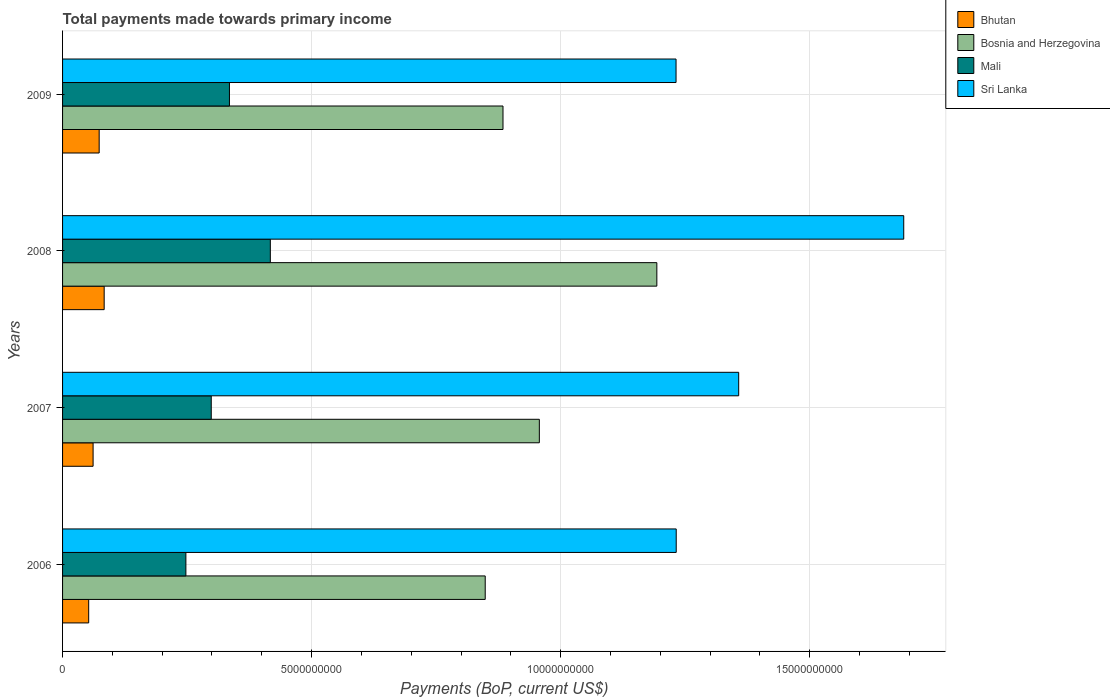How many groups of bars are there?
Provide a short and direct response. 4. How many bars are there on the 2nd tick from the top?
Provide a succinct answer. 4. What is the total payments made towards primary income in Mali in 2009?
Provide a short and direct response. 3.35e+09. Across all years, what is the maximum total payments made towards primary income in Sri Lanka?
Your answer should be very brief. 1.69e+1. Across all years, what is the minimum total payments made towards primary income in Sri Lanka?
Ensure brevity in your answer.  1.23e+1. What is the total total payments made towards primary income in Mali in the graph?
Give a very brief answer. 1.30e+1. What is the difference between the total payments made towards primary income in Mali in 2007 and that in 2009?
Your response must be concise. -3.65e+08. What is the difference between the total payments made towards primary income in Bosnia and Herzegovina in 2006 and the total payments made towards primary income in Mali in 2008?
Your answer should be very brief. 4.31e+09. What is the average total payments made towards primary income in Mali per year?
Offer a very short reply. 3.25e+09. In the year 2009, what is the difference between the total payments made towards primary income in Sri Lanka and total payments made towards primary income in Bosnia and Herzegovina?
Provide a short and direct response. 3.47e+09. What is the ratio of the total payments made towards primary income in Bosnia and Herzegovina in 2006 to that in 2008?
Ensure brevity in your answer.  0.71. Is the total payments made towards primary income in Bhutan in 2006 less than that in 2008?
Keep it short and to the point. Yes. Is the difference between the total payments made towards primary income in Sri Lanka in 2006 and 2009 greater than the difference between the total payments made towards primary income in Bosnia and Herzegovina in 2006 and 2009?
Your response must be concise. Yes. What is the difference between the highest and the second highest total payments made towards primary income in Mali?
Keep it short and to the point. 8.21e+08. What is the difference between the highest and the lowest total payments made towards primary income in Bosnia and Herzegovina?
Your answer should be very brief. 3.45e+09. Is it the case that in every year, the sum of the total payments made towards primary income in Bosnia and Herzegovina and total payments made towards primary income in Bhutan is greater than the sum of total payments made towards primary income in Sri Lanka and total payments made towards primary income in Mali?
Ensure brevity in your answer.  No. What does the 3rd bar from the top in 2007 represents?
Your response must be concise. Bosnia and Herzegovina. What does the 3rd bar from the bottom in 2009 represents?
Provide a succinct answer. Mali. How many bars are there?
Ensure brevity in your answer.  16. What is the difference between two consecutive major ticks on the X-axis?
Provide a succinct answer. 5.00e+09. Are the values on the major ticks of X-axis written in scientific E-notation?
Give a very brief answer. No. Does the graph contain any zero values?
Ensure brevity in your answer.  No. Where does the legend appear in the graph?
Offer a very short reply. Top right. What is the title of the graph?
Your answer should be very brief. Total payments made towards primary income. What is the label or title of the X-axis?
Offer a terse response. Payments (BoP, current US$). What is the label or title of the Y-axis?
Offer a very short reply. Years. What is the Payments (BoP, current US$) in Bhutan in 2006?
Keep it short and to the point. 5.25e+08. What is the Payments (BoP, current US$) in Bosnia and Herzegovina in 2006?
Keep it short and to the point. 8.49e+09. What is the Payments (BoP, current US$) in Mali in 2006?
Give a very brief answer. 2.48e+09. What is the Payments (BoP, current US$) of Sri Lanka in 2006?
Give a very brief answer. 1.23e+1. What is the Payments (BoP, current US$) of Bhutan in 2007?
Offer a terse response. 6.13e+08. What is the Payments (BoP, current US$) of Bosnia and Herzegovina in 2007?
Give a very brief answer. 9.57e+09. What is the Payments (BoP, current US$) of Mali in 2007?
Ensure brevity in your answer.  2.99e+09. What is the Payments (BoP, current US$) of Sri Lanka in 2007?
Your answer should be very brief. 1.36e+1. What is the Payments (BoP, current US$) of Bhutan in 2008?
Your response must be concise. 8.35e+08. What is the Payments (BoP, current US$) in Bosnia and Herzegovina in 2008?
Offer a very short reply. 1.19e+1. What is the Payments (BoP, current US$) of Mali in 2008?
Give a very brief answer. 4.17e+09. What is the Payments (BoP, current US$) of Sri Lanka in 2008?
Ensure brevity in your answer.  1.69e+1. What is the Payments (BoP, current US$) in Bhutan in 2009?
Make the answer very short. 7.35e+08. What is the Payments (BoP, current US$) of Bosnia and Herzegovina in 2009?
Make the answer very short. 8.84e+09. What is the Payments (BoP, current US$) of Mali in 2009?
Make the answer very short. 3.35e+09. What is the Payments (BoP, current US$) of Sri Lanka in 2009?
Offer a terse response. 1.23e+1. Across all years, what is the maximum Payments (BoP, current US$) of Bhutan?
Give a very brief answer. 8.35e+08. Across all years, what is the maximum Payments (BoP, current US$) of Bosnia and Herzegovina?
Your response must be concise. 1.19e+1. Across all years, what is the maximum Payments (BoP, current US$) in Mali?
Offer a very short reply. 4.17e+09. Across all years, what is the maximum Payments (BoP, current US$) of Sri Lanka?
Make the answer very short. 1.69e+1. Across all years, what is the minimum Payments (BoP, current US$) of Bhutan?
Offer a very short reply. 5.25e+08. Across all years, what is the minimum Payments (BoP, current US$) in Bosnia and Herzegovina?
Provide a short and direct response. 8.49e+09. Across all years, what is the minimum Payments (BoP, current US$) in Mali?
Your response must be concise. 2.48e+09. Across all years, what is the minimum Payments (BoP, current US$) of Sri Lanka?
Give a very brief answer. 1.23e+1. What is the total Payments (BoP, current US$) in Bhutan in the graph?
Offer a terse response. 2.71e+09. What is the total Payments (BoP, current US$) in Bosnia and Herzegovina in the graph?
Provide a short and direct response. 3.88e+1. What is the total Payments (BoP, current US$) in Mali in the graph?
Your answer should be very brief. 1.30e+1. What is the total Payments (BoP, current US$) in Sri Lanka in the graph?
Offer a very short reply. 5.51e+1. What is the difference between the Payments (BoP, current US$) of Bhutan in 2006 and that in 2007?
Offer a very short reply. -8.84e+07. What is the difference between the Payments (BoP, current US$) in Bosnia and Herzegovina in 2006 and that in 2007?
Give a very brief answer. -1.09e+09. What is the difference between the Payments (BoP, current US$) in Mali in 2006 and that in 2007?
Provide a short and direct response. -5.09e+08. What is the difference between the Payments (BoP, current US$) of Sri Lanka in 2006 and that in 2007?
Your response must be concise. -1.25e+09. What is the difference between the Payments (BoP, current US$) in Bhutan in 2006 and that in 2008?
Ensure brevity in your answer.  -3.11e+08. What is the difference between the Payments (BoP, current US$) of Bosnia and Herzegovina in 2006 and that in 2008?
Your response must be concise. -3.45e+09. What is the difference between the Payments (BoP, current US$) of Mali in 2006 and that in 2008?
Keep it short and to the point. -1.70e+09. What is the difference between the Payments (BoP, current US$) in Sri Lanka in 2006 and that in 2008?
Make the answer very short. -4.57e+09. What is the difference between the Payments (BoP, current US$) of Bhutan in 2006 and that in 2009?
Your response must be concise. -2.10e+08. What is the difference between the Payments (BoP, current US$) in Bosnia and Herzegovina in 2006 and that in 2009?
Your response must be concise. -3.57e+08. What is the difference between the Payments (BoP, current US$) in Mali in 2006 and that in 2009?
Make the answer very short. -8.75e+08. What is the difference between the Payments (BoP, current US$) in Sri Lanka in 2006 and that in 2009?
Provide a short and direct response. 3.42e+06. What is the difference between the Payments (BoP, current US$) of Bhutan in 2007 and that in 2008?
Make the answer very short. -2.22e+08. What is the difference between the Payments (BoP, current US$) in Bosnia and Herzegovina in 2007 and that in 2008?
Keep it short and to the point. -2.36e+09. What is the difference between the Payments (BoP, current US$) in Mali in 2007 and that in 2008?
Keep it short and to the point. -1.19e+09. What is the difference between the Payments (BoP, current US$) in Sri Lanka in 2007 and that in 2008?
Your response must be concise. -3.31e+09. What is the difference between the Payments (BoP, current US$) of Bhutan in 2007 and that in 2009?
Keep it short and to the point. -1.22e+08. What is the difference between the Payments (BoP, current US$) in Bosnia and Herzegovina in 2007 and that in 2009?
Keep it short and to the point. 7.30e+08. What is the difference between the Payments (BoP, current US$) of Mali in 2007 and that in 2009?
Your answer should be very brief. -3.65e+08. What is the difference between the Payments (BoP, current US$) of Sri Lanka in 2007 and that in 2009?
Your response must be concise. 1.26e+09. What is the difference between the Payments (BoP, current US$) in Bhutan in 2008 and that in 2009?
Ensure brevity in your answer.  1.00e+08. What is the difference between the Payments (BoP, current US$) of Bosnia and Herzegovina in 2008 and that in 2009?
Ensure brevity in your answer.  3.09e+09. What is the difference between the Payments (BoP, current US$) in Mali in 2008 and that in 2009?
Your answer should be very brief. 8.21e+08. What is the difference between the Payments (BoP, current US$) in Sri Lanka in 2008 and that in 2009?
Give a very brief answer. 4.57e+09. What is the difference between the Payments (BoP, current US$) of Bhutan in 2006 and the Payments (BoP, current US$) of Bosnia and Herzegovina in 2007?
Give a very brief answer. -9.05e+09. What is the difference between the Payments (BoP, current US$) in Bhutan in 2006 and the Payments (BoP, current US$) in Mali in 2007?
Provide a short and direct response. -2.46e+09. What is the difference between the Payments (BoP, current US$) of Bhutan in 2006 and the Payments (BoP, current US$) of Sri Lanka in 2007?
Keep it short and to the point. -1.31e+1. What is the difference between the Payments (BoP, current US$) of Bosnia and Herzegovina in 2006 and the Payments (BoP, current US$) of Mali in 2007?
Provide a short and direct response. 5.50e+09. What is the difference between the Payments (BoP, current US$) of Bosnia and Herzegovina in 2006 and the Payments (BoP, current US$) of Sri Lanka in 2007?
Provide a short and direct response. -5.09e+09. What is the difference between the Payments (BoP, current US$) of Mali in 2006 and the Payments (BoP, current US$) of Sri Lanka in 2007?
Your answer should be compact. -1.11e+1. What is the difference between the Payments (BoP, current US$) of Bhutan in 2006 and the Payments (BoP, current US$) of Bosnia and Herzegovina in 2008?
Keep it short and to the point. -1.14e+1. What is the difference between the Payments (BoP, current US$) in Bhutan in 2006 and the Payments (BoP, current US$) in Mali in 2008?
Offer a terse response. -3.65e+09. What is the difference between the Payments (BoP, current US$) of Bhutan in 2006 and the Payments (BoP, current US$) of Sri Lanka in 2008?
Your response must be concise. -1.64e+1. What is the difference between the Payments (BoP, current US$) in Bosnia and Herzegovina in 2006 and the Payments (BoP, current US$) in Mali in 2008?
Your answer should be very brief. 4.31e+09. What is the difference between the Payments (BoP, current US$) of Bosnia and Herzegovina in 2006 and the Payments (BoP, current US$) of Sri Lanka in 2008?
Keep it short and to the point. -8.40e+09. What is the difference between the Payments (BoP, current US$) of Mali in 2006 and the Payments (BoP, current US$) of Sri Lanka in 2008?
Offer a very short reply. -1.44e+1. What is the difference between the Payments (BoP, current US$) in Bhutan in 2006 and the Payments (BoP, current US$) in Bosnia and Herzegovina in 2009?
Offer a very short reply. -8.32e+09. What is the difference between the Payments (BoP, current US$) of Bhutan in 2006 and the Payments (BoP, current US$) of Mali in 2009?
Your answer should be compact. -2.83e+09. What is the difference between the Payments (BoP, current US$) of Bhutan in 2006 and the Payments (BoP, current US$) of Sri Lanka in 2009?
Your answer should be compact. -1.18e+1. What is the difference between the Payments (BoP, current US$) in Bosnia and Herzegovina in 2006 and the Payments (BoP, current US$) in Mali in 2009?
Offer a very short reply. 5.14e+09. What is the difference between the Payments (BoP, current US$) in Bosnia and Herzegovina in 2006 and the Payments (BoP, current US$) in Sri Lanka in 2009?
Provide a succinct answer. -3.83e+09. What is the difference between the Payments (BoP, current US$) of Mali in 2006 and the Payments (BoP, current US$) of Sri Lanka in 2009?
Your answer should be compact. -9.84e+09. What is the difference between the Payments (BoP, current US$) of Bhutan in 2007 and the Payments (BoP, current US$) of Bosnia and Herzegovina in 2008?
Provide a short and direct response. -1.13e+1. What is the difference between the Payments (BoP, current US$) of Bhutan in 2007 and the Payments (BoP, current US$) of Mali in 2008?
Keep it short and to the point. -3.56e+09. What is the difference between the Payments (BoP, current US$) in Bhutan in 2007 and the Payments (BoP, current US$) in Sri Lanka in 2008?
Provide a succinct answer. -1.63e+1. What is the difference between the Payments (BoP, current US$) in Bosnia and Herzegovina in 2007 and the Payments (BoP, current US$) in Mali in 2008?
Your response must be concise. 5.40e+09. What is the difference between the Payments (BoP, current US$) of Bosnia and Herzegovina in 2007 and the Payments (BoP, current US$) of Sri Lanka in 2008?
Your answer should be compact. -7.32e+09. What is the difference between the Payments (BoP, current US$) of Mali in 2007 and the Payments (BoP, current US$) of Sri Lanka in 2008?
Offer a terse response. -1.39e+1. What is the difference between the Payments (BoP, current US$) in Bhutan in 2007 and the Payments (BoP, current US$) in Bosnia and Herzegovina in 2009?
Your answer should be compact. -8.23e+09. What is the difference between the Payments (BoP, current US$) of Bhutan in 2007 and the Payments (BoP, current US$) of Mali in 2009?
Give a very brief answer. -2.74e+09. What is the difference between the Payments (BoP, current US$) in Bhutan in 2007 and the Payments (BoP, current US$) in Sri Lanka in 2009?
Your response must be concise. -1.17e+1. What is the difference between the Payments (BoP, current US$) in Bosnia and Herzegovina in 2007 and the Payments (BoP, current US$) in Mali in 2009?
Your answer should be very brief. 6.22e+09. What is the difference between the Payments (BoP, current US$) in Bosnia and Herzegovina in 2007 and the Payments (BoP, current US$) in Sri Lanka in 2009?
Provide a short and direct response. -2.74e+09. What is the difference between the Payments (BoP, current US$) of Mali in 2007 and the Payments (BoP, current US$) of Sri Lanka in 2009?
Provide a short and direct response. -9.33e+09. What is the difference between the Payments (BoP, current US$) of Bhutan in 2008 and the Payments (BoP, current US$) of Bosnia and Herzegovina in 2009?
Your answer should be compact. -8.01e+09. What is the difference between the Payments (BoP, current US$) in Bhutan in 2008 and the Payments (BoP, current US$) in Mali in 2009?
Make the answer very short. -2.52e+09. What is the difference between the Payments (BoP, current US$) in Bhutan in 2008 and the Payments (BoP, current US$) in Sri Lanka in 2009?
Offer a terse response. -1.15e+1. What is the difference between the Payments (BoP, current US$) of Bosnia and Herzegovina in 2008 and the Payments (BoP, current US$) of Mali in 2009?
Keep it short and to the point. 8.58e+09. What is the difference between the Payments (BoP, current US$) of Bosnia and Herzegovina in 2008 and the Payments (BoP, current US$) of Sri Lanka in 2009?
Your answer should be very brief. -3.85e+08. What is the difference between the Payments (BoP, current US$) of Mali in 2008 and the Payments (BoP, current US$) of Sri Lanka in 2009?
Provide a short and direct response. -8.15e+09. What is the average Payments (BoP, current US$) in Bhutan per year?
Offer a terse response. 6.77e+08. What is the average Payments (BoP, current US$) in Bosnia and Herzegovina per year?
Your response must be concise. 9.71e+09. What is the average Payments (BoP, current US$) in Mali per year?
Offer a very short reply. 3.25e+09. What is the average Payments (BoP, current US$) of Sri Lanka per year?
Your answer should be compact. 1.38e+1. In the year 2006, what is the difference between the Payments (BoP, current US$) of Bhutan and Payments (BoP, current US$) of Bosnia and Herzegovina?
Provide a short and direct response. -7.96e+09. In the year 2006, what is the difference between the Payments (BoP, current US$) in Bhutan and Payments (BoP, current US$) in Mali?
Provide a short and direct response. -1.95e+09. In the year 2006, what is the difference between the Payments (BoP, current US$) of Bhutan and Payments (BoP, current US$) of Sri Lanka?
Offer a very short reply. -1.18e+1. In the year 2006, what is the difference between the Payments (BoP, current US$) of Bosnia and Herzegovina and Payments (BoP, current US$) of Mali?
Offer a terse response. 6.01e+09. In the year 2006, what is the difference between the Payments (BoP, current US$) of Bosnia and Herzegovina and Payments (BoP, current US$) of Sri Lanka?
Your answer should be very brief. -3.83e+09. In the year 2006, what is the difference between the Payments (BoP, current US$) of Mali and Payments (BoP, current US$) of Sri Lanka?
Your response must be concise. -9.84e+09. In the year 2007, what is the difference between the Payments (BoP, current US$) of Bhutan and Payments (BoP, current US$) of Bosnia and Herzegovina?
Your response must be concise. -8.96e+09. In the year 2007, what is the difference between the Payments (BoP, current US$) of Bhutan and Payments (BoP, current US$) of Mali?
Offer a very short reply. -2.37e+09. In the year 2007, what is the difference between the Payments (BoP, current US$) in Bhutan and Payments (BoP, current US$) in Sri Lanka?
Keep it short and to the point. -1.30e+1. In the year 2007, what is the difference between the Payments (BoP, current US$) of Bosnia and Herzegovina and Payments (BoP, current US$) of Mali?
Offer a very short reply. 6.59e+09. In the year 2007, what is the difference between the Payments (BoP, current US$) in Bosnia and Herzegovina and Payments (BoP, current US$) in Sri Lanka?
Make the answer very short. -4.00e+09. In the year 2007, what is the difference between the Payments (BoP, current US$) of Mali and Payments (BoP, current US$) of Sri Lanka?
Offer a very short reply. -1.06e+1. In the year 2008, what is the difference between the Payments (BoP, current US$) in Bhutan and Payments (BoP, current US$) in Bosnia and Herzegovina?
Make the answer very short. -1.11e+1. In the year 2008, what is the difference between the Payments (BoP, current US$) in Bhutan and Payments (BoP, current US$) in Mali?
Make the answer very short. -3.34e+09. In the year 2008, what is the difference between the Payments (BoP, current US$) in Bhutan and Payments (BoP, current US$) in Sri Lanka?
Give a very brief answer. -1.61e+1. In the year 2008, what is the difference between the Payments (BoP, current US$) of Bosnia and Herzegovina and Payments (BoP, current US$) of Mali?
Your response must be concise. 7.76e+09. In the year 2008, what is the difference between the Payments (BoP, current US$) in Bosnia and Herzegovina and Payments (BoP, current US$) in Sri Lanka?
Ensure brevity in your answer.  -4.96e+09. In the year 2008, what is the difference between the Payments (BoP, current US$) of Mali and Payments (BoP, current US$) of Sri Lanka?
Your answer should be compact. -1.27e+1. In the year 2009, what is the difference between the Payments (BoP, current US$) of Bhutan and Payments (BoP, current US$) of Bosnia and Herzegovina?
Provide a short and direct response. -8.11e+09. In the year 2009, what is the difference between the Payments (BoP, current US$) of Bhutan and Payments (BoP, current US$) of Mali?
Give a very brief answer. -2.62e+09. In the year 2009, what is the difference between the Payments (BoP, current US$) in Bhutan and Payments (BoP, current US$) in Sri Lanka?
Offer a very short reply. -1.16e+1. In the year 2009, what is the difference between the Payments (BoP, current US$) in Bosnia and Herzegovina and Payments (BoP, current US$) in Mali?
Make the answer very short. 5.49e+09. In the year 2009, what is the difference between the Payments (BoP, current US$) in Bosnia and Herzegovina and Payments (BoP, current US$) in Sri Lanka?
Offer a terse response. -3.47e+09. In the year 2009, what is the difference between the Payments (BoP, current US$) of Mali and Payments (BoP, current US$) of Sri Lanka?
Make the answer very short. -8.97e+09. What is the ratio of the Payments (BoP, current US$) of Bhutan in 2006 to that in 2007?
Your response must be concise. 0.86. What is the ratio of the Payments (BoP, current US$) of Bosnia and Herzegovina in 2006 to that in 2007?
Offer a very short reply. 0.89. What is the ratio of the Payments (BoP, current US$) in Mali in 2006 to that in 2007?
Keep it short and to the point. 0.83. What is the ratio of the Payments (BoP, current US$) of Sri Lanka in 2006 to that in 2007?
Offer a terse response. 0.91. What is the ratio of the Payments (BoP, current US$) of Bhutan in 2006 to that in 2008?
Provide a succinct answer. 0.63. What is the ratio of the Payments (BoP, current US$) in Bosnia and Herzegovina in 2006 to that in 2008?
Give a very brief answer. 0.71. What is the ratio of the Payments (BoP, current US$) of Mali in 2006 to that in 2008?
Give a very brief answer. 0.59. What is the ratio of the Payments (BoP, current US$) of Sri Lanka in 2006 to that in 2008?
Offer a terse response. 0.73. What is the ratio of the Payments (BoP, current US$) of Bhutan in 2006 to that in 2009?
Keep it short and to the point. 0.71. What is the ratio of the Payments (BoP, current US$) of Bosnia and Herzegovina in 2006 to that in 2009?
Your answer should be compact. 0.96. What is the ratio of the Payments (BoP, current US$) of Mali in 2006 to that in 2009?
Ensure brevity in your answer.  0.74. What is the ratio of the Payments (BoP, current US$) in Bhutan in 2007 to that in 2008?
Offer a very short reply. 0.73. What is the ratio of the Payments (BoP, current US$) in Bosnia and Herzegovina in 2007 to that in 2008?
Keep it short and to the point. 0.8. What is the ratio of the Payments (BoP, current US$) in Mali in 2007 to that in 2008?
Make the answer very short. 0.72. What is the ratio of the Payments (BoP, current US$) in Sri Lanka in 2007 to that in 2008?
Keep it short and to the point. 0.8. What is the ratio of the Payments (BoP, current US$) in Bhutan in 2007 to that in 2009?
Provide a short and direct response. 0.83. What is the ratio of the Payments (BoP, current US$) in Bosnia and Herzegovina in 2007 to that in 2009?
Provide a succinct answer. 1.08. What is the ratio of the Payments (BoP, current US$) in Mali in 2007 to that in 2009?
Your answer should be compact. 0.89. What is the ratio of the Payments (BoP, current US$) in Sri Lanka in 2007 to that in 2009?
Offer a terse response. 1.1. What is the ratio of the Payments (BoP, current US$) in Bhutan in 2008 to that in 2009?
Your answer should be compact. 1.14. What is the ratio of the Payments (BoP, current US$) of Bosnia and Herzegovina in 2008 to that in 2009?
Your response must be concise. 1.35. What is the ratio of the Payments (BoP, current US$) in Mali in 2008 to that in 2009?
Make the answer very short. 1.24. What is the ratio of the Payments (BoP, current US$) of Sri Lanka in 2008 to that in 2009?
Your response must be concise. 1.37. What is the difference between the highest and the second highest Payments (BoP, current US$) in Bhutan?
Your answer should be compact. 1.00e+08. What is the difference between the highest and the second highest Payments (BoP, current US$) of Bosnia and Herzegovina?
Ensure brevity in your answer.  2.36e+09. What is the difference between the highest and the second highest Payments (BoP, current US$) in Mali?
Offer a very short reply. 8.21e+08. What is the difference between the highest and the second highest Payments (BoP, current US$) in Sri Lanka?
Your answer should be compact. 3.31e+09. What is the difference between the highest and the lowest Payments (BoP, current US$) of Bhutan?
Your answer should be compact. 3.11e+08. What is the difference between the highest and the lowest Payments (BoP, current US$) of Bosnia and Herzegovina?
Provide a succinct answer. 3.45e+09. What is the difference between the highest and the lowest Payments (BoP, current US$) in Mali?
Your answer should be compact. 1.70e+09. What is the difference between the highest and the lowest Payments (BoP, current US$) in Sri Lanka?
Provide a short and direct response. 4.57e+09. 